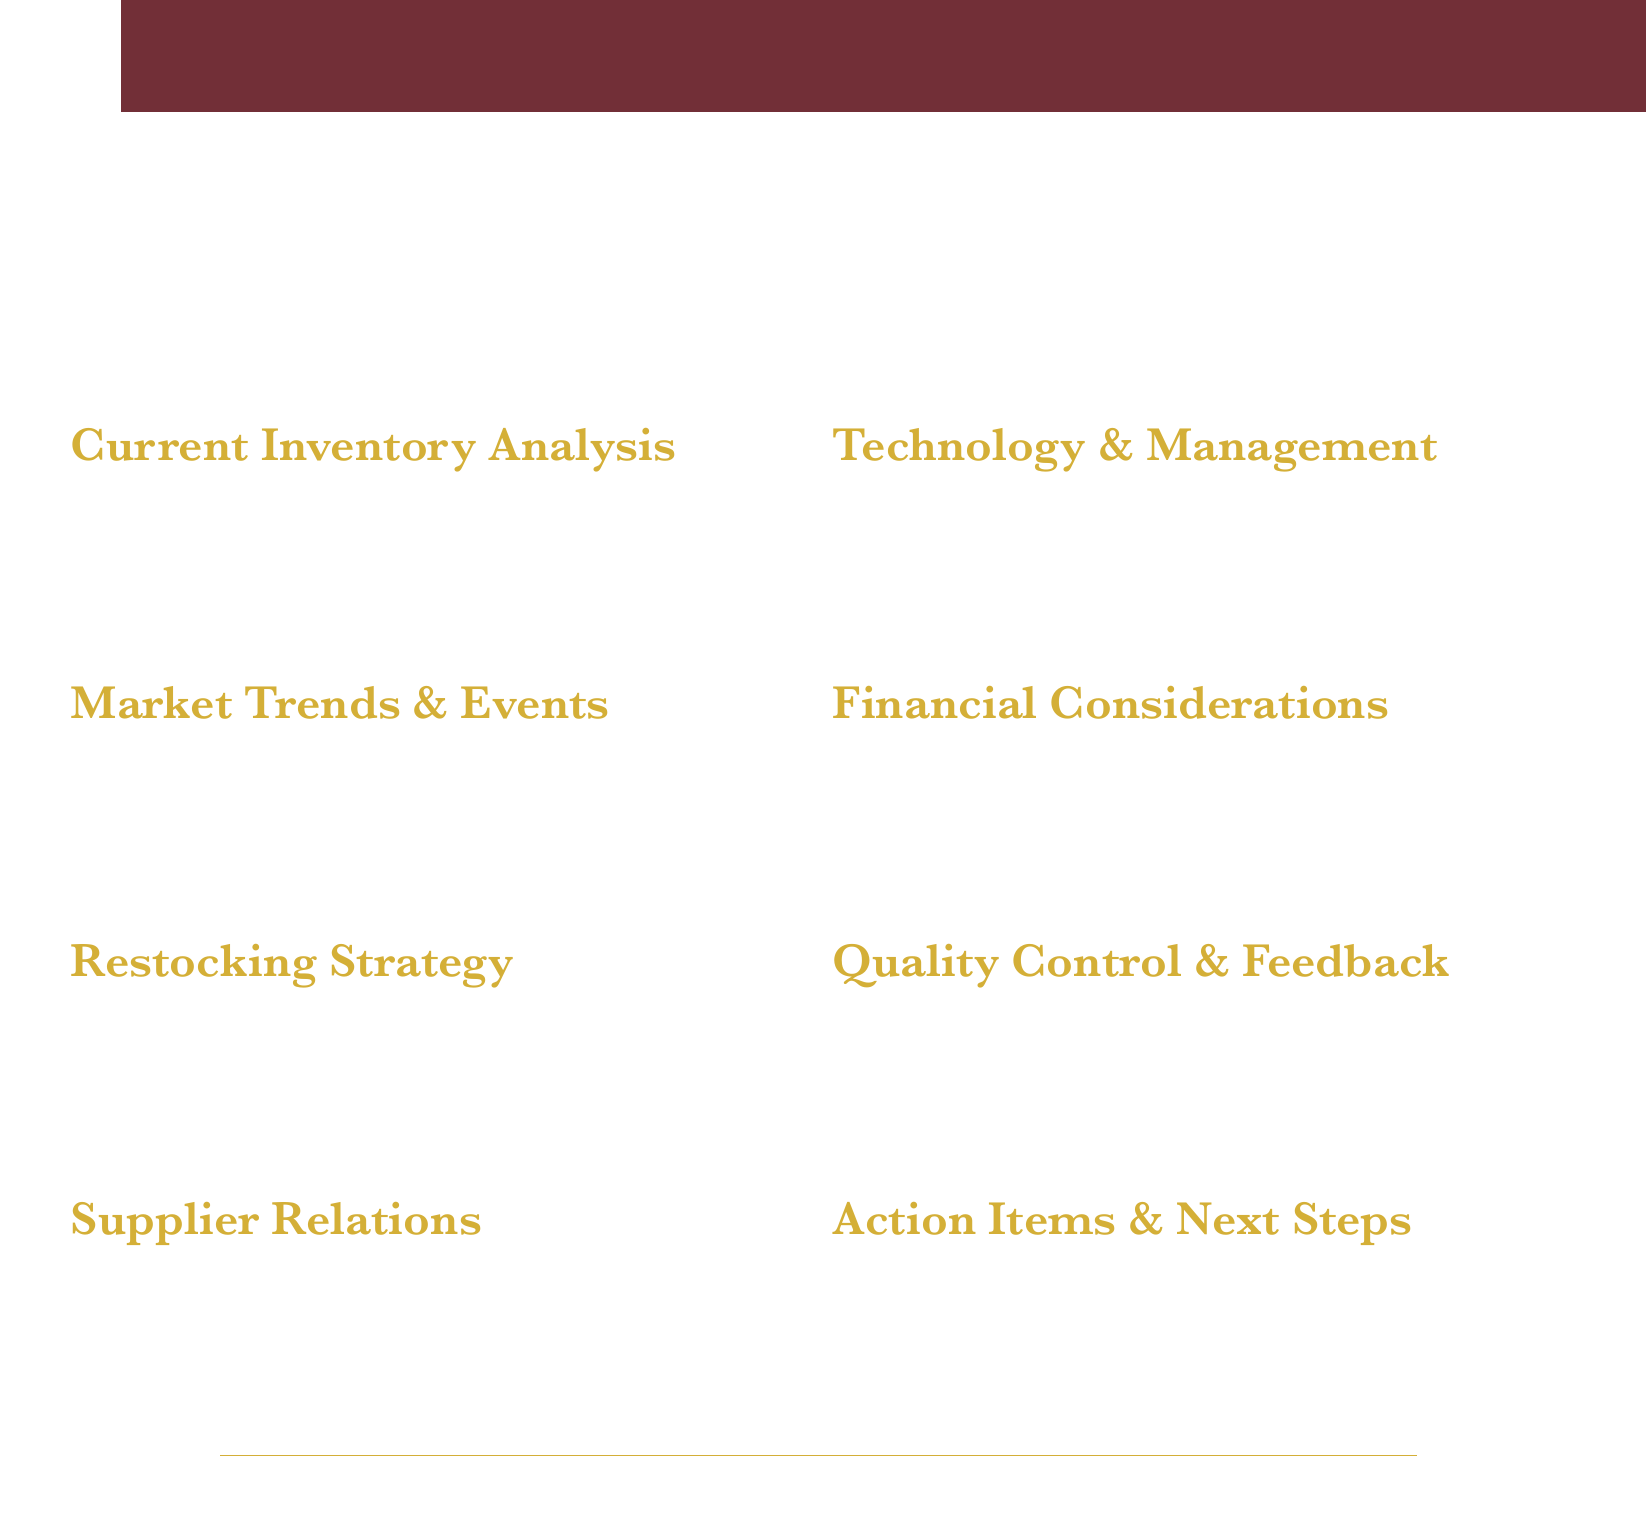What is the date of the meeting? The date of the meeting is explicitly stated in the document as September 15, 2023.
Answer: September 15, 2023 Where is the meeting location? The document specifies that the meeting will take place at Château Margaux Tasting Room.
Answer: Château Margaux Tasting Room Who are the attendees? The document lists the attendees as Head Sommelier, Inventory Manager, Event Planning Director, and Finance Manager.
Answer: Head Sommelier, Inventory Manager, Event Planning Director, Finance Manager What wine region is identified as emerging in the restocking strategy? The document mentions Priorat and Walla Walla Valley as the emerging wine regions.
Answer: Priorat, Walla Walla Valley What is one discussion topic regarding market trends? The document states that the rising popularity of natural wines is one of the topics for discussion.
Answer: Rising popularity of natural wines What is the proposed action related to technology management? The document proposes the implementation of new cellar management software (CellarTracker) for improved inventory control.
Answer: Implementation of new cellar management software How many sections are in the agenda? The agenda includes a total of seven sections as detailed in the document.
Answer: Seven What will be reviewed under quality control and customer feedback? The review of client satisfaction surveys from recent events is an item included in this section.
Answer: Client satisfaction surveys from recent events What is the main purpose of the meeting? The purpose of the meeting is to review high-end wine inventory and restocking plans, as highlighted in the title of the agenda.
Answer: Review high-end wine inventory and restocking plans 